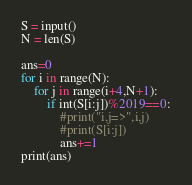Convert code to text. <code><loc_0><loc_0><loc_500><loc_500><_Python_>S = input()
N = len(S)

ans=0
for i in range(N):
    for j in range(i+4,N+1):
        if int(S[i:j])%2019==0:
            #print("i,j=>",i,j)
            #print(S[i:j])
            ans+=1
print(ans)



</code> 